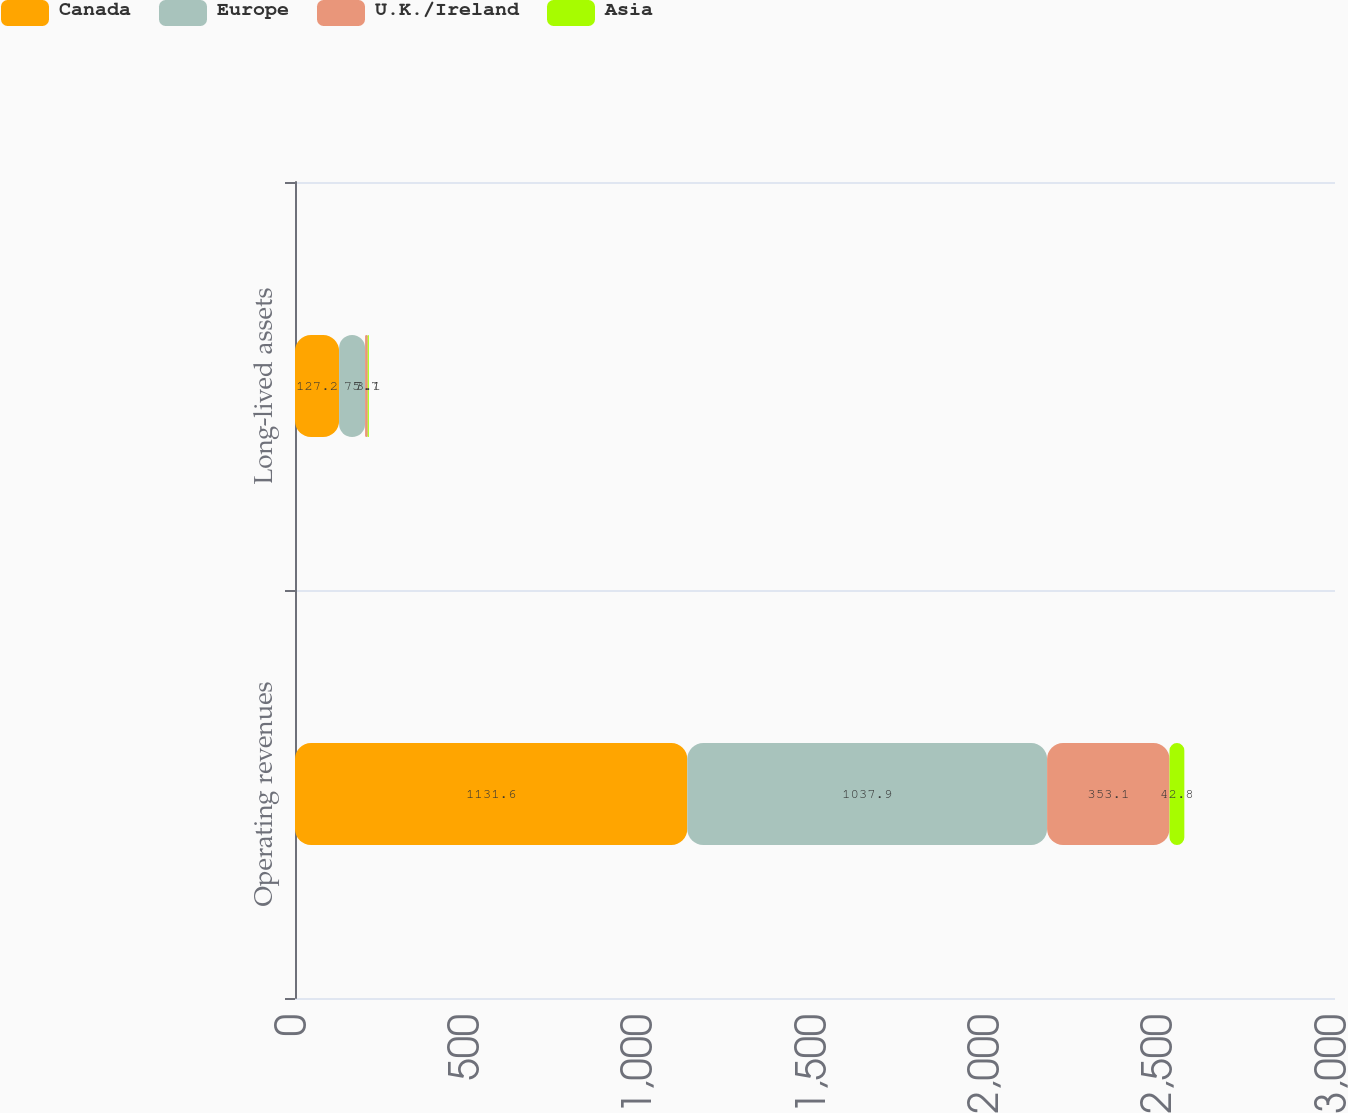Convert chart to OTSL. <chart><loc_0><loc_0><loc_500><loc_500><stacked_bar_chart><ecel><fcel>Operating revenues<fcel>Long-lived assets<nl><fcel>Canada<fcel>1131.6<fcel>127.2<nl><fcel>Europe<fcel>1037.9<fcel>75<nl><fcel>U.K./Ireland<fcel>353.1<fcel>7.7<nl><fcel>Asia<fcel>42.8<fcel>3.1<nl></chart> 